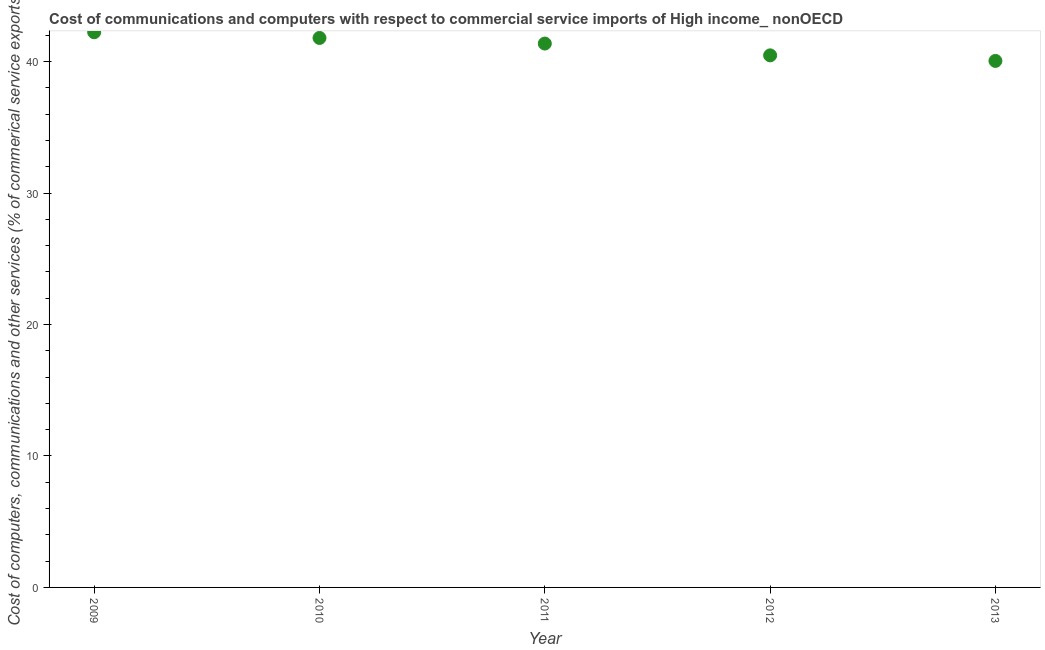What is the cost of communications in 2013?
Your response must be concise. 40.06. Across all years, what is the maximum  computer and other services?
Offer a terse response. 42.24. Across all years, what is the minimum  computer and other services?
Keep it short and to the point. 40.06. In which year was the  computer and other services minimum?
Ensure brevity in your answer.  2013. What is the sum of the  computer and other services?
Provide a short and direct response. 205.95. What is the difference between the  computer and other services in 2009 and 2012?
Make the answer very short. 1.76. What is the average cost of communications per year?
Provide a short and direct response. 41.19. What is the median  computer and other services?
Your answer should be compact. 41.38. Do a majority of the years between 2013 and 2010 (inclusive) have  computer and other services greater than 12 %?
Provide a short and direct response. Yes. What is the ratio of the  computer and other services in 2009 to that in 2012?
Make the answer very short. 1.04. Is the  computer and other services in 2009 less than that in 2011?
Offer a terse response. No. Is the difference between the  computer and other services in 2009 and 2010 greater than the difference between any two years?
Give a very brief answer. No. What is the difference between the highest and the second highest  computer and other services?
Offer a terse response. 0.43. Is the sum of the  computer and other services in 2011 and 2013 greater than the maximum  computer and other services across all years?
Your answer should be very brief. Yes. What is the difference between the highest and the lowest cost of communications?
Make the answer very short. 2.18. In how many years, is the cost of communications greater than the average cost of communications taken over all years?
Make the answer very short. 3. Does the  computer and other services monotonically increase over the years?
Offer a very short reply. No. How many dotlines are there?
Provide a short and direct response. 1. How many years are there in the graph?
Provide a succinct answer. 5. Are the values on the major ticks of Y-axis written in scientific E-notation?
Provide a succinct answer. No. What is the title of the graph?
Ensure brevity in your answer.  Cost of communications and computers with respect to commercial service imports of High income_ nonOECD. What is the label or title of the Y-axis?
Your answer should be very brief. Cost of computers, communications and other services (% of commerical service exports). What is the Cost of computers, communications and other services (% of commerical service exports) in 2009?
Keep it short and to the point. 42.24. What is the Cost of computers, communications and other services (% of commerical service exports) in 2010?
Make the answer very short. 41.8. What is the Cost of computers, communications and other services (% of commerical service exports) in 2011?
Make the answer very short. 41.38. What is the Cost of computers, communications and other services (% of commerical service exports) in 2012?
Provide a succinct answer. 40.48. What is the Cost of computers, communications and other services (% of commerical service exports) in 2013?
Keep it short and to the point. 40.06. What is the difference between the Cost of computers, communications and other services (% of commerical service exports) in 2009 and 2010?
Your response must be concise. 0.43. What is the difference between the Cost of computers, communications and other services (% of commerical service exports) in 2009 and 2011?
Your response must be concise. 0.86. What is the difference between the Cost of computers, communications and other services (% of commerical service exports) in 2009 and 2012?
Your answer should be very brief. 1.76. What is the difference between the Cost of computers, communications and other services (% of commerical service exports) in 2009 and 2013?
Provide a succinct answer. 2.18. What is the difference between the Cost of computers, communications and other services (% of commerical service exports) in 2010 and 2011?
Offer a very short reply. 0.43. What is the difference between the Cost of computers, communications and other services (% of commerical service exports) in 2010 and 2012?
Ensure brevity in your answer.  1.32. What is the difference between the Cost of computers, communications and other services (% of commerical service exports) in 2010 and 2013?
Give a very brief answer. 1.75. What is the difference between the Cost of computers, communications and other services (% of commerical service exports) in 2011 and 2012?
Give a very brief answer. 0.9. What is the difference between the Cost of computers, communications and other services (% of commerical service exports) in 2011 and 2013?
Make the answer very short. 1.32. What is the difference between the Cost of computers, communications and other services (% of commerical service exports) in 2012 and 2013?
Your response must be concise. 0.42. What is the ratio of the Cost of computers, communications and other services (% of commerical service exports) in 2009 to that in 2012?
Keep it short and to the point. 1.04. What is the ratio of the Cost of computers, communications and other services (% of commerical service exports) in 2009 to that in 2013?
Provide a short and direct response. 1.05. What is the ratio of the Cost of computers, communications and other services (% of commerical service exports) in 2010 to that in 2012?
Make the answer very short. 1.03. What is the ratio of the Cost of computers, communications and other services (% of commerical service exports) in 2010 to that in 2013?
Make the answer very short. 1.04. What is the ratio of the Cost of computers, communications and other services (% of commerical service exports) in 2011 to that in 2013?
Your answer should be very brief. 1.03. What is the ratio of the Cost of computers, communications and other services (% of commerical service exports) in 2012 to that in 2013?
Offer a very short reply. 1.01. 